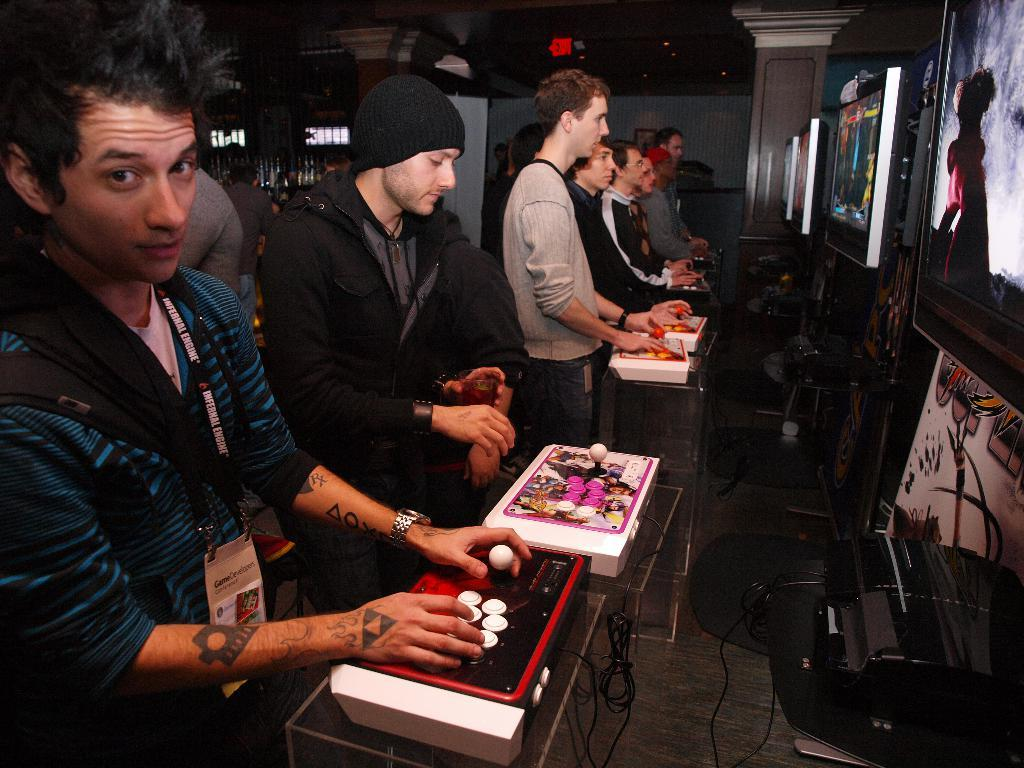What are the people in the image doing? The people in the image are standing and playing video games. How are the people interacting with the video games? The people are pressing buttons and holding joysticks while playing. What can be seen connected to the video game consoles? There are cables visible in the image. Where are the televisions located in the image? The televisions are fixed to the wall in the image. Can you tell me how many snails are crawling on the floor in the image? There are no snails visible in the image; the focus is on the people playing video games. What type of yak is present in the image? There is no yak present in the image; the focus is on the people playing video games and their interaction with the video game consoles and televisions. 